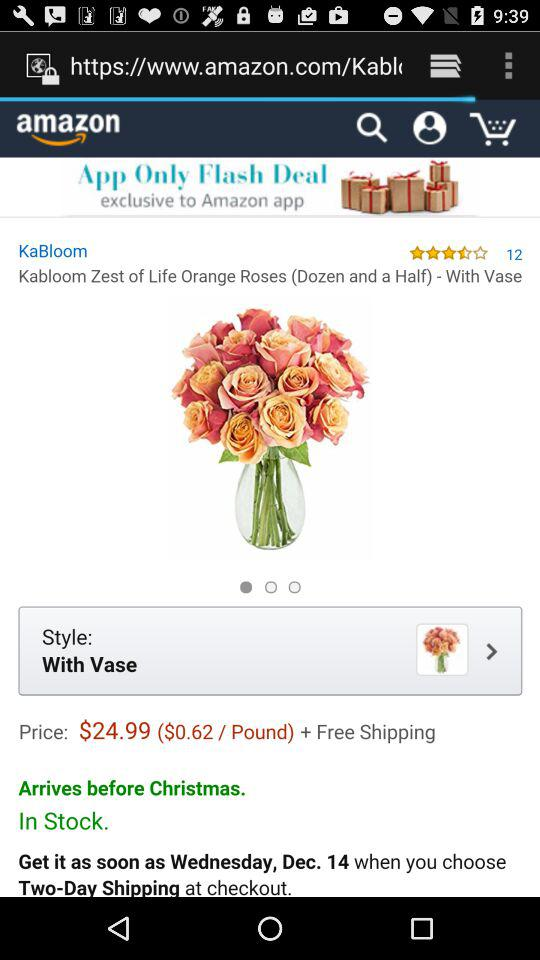How many reviews are there? There are 12 reviews. 